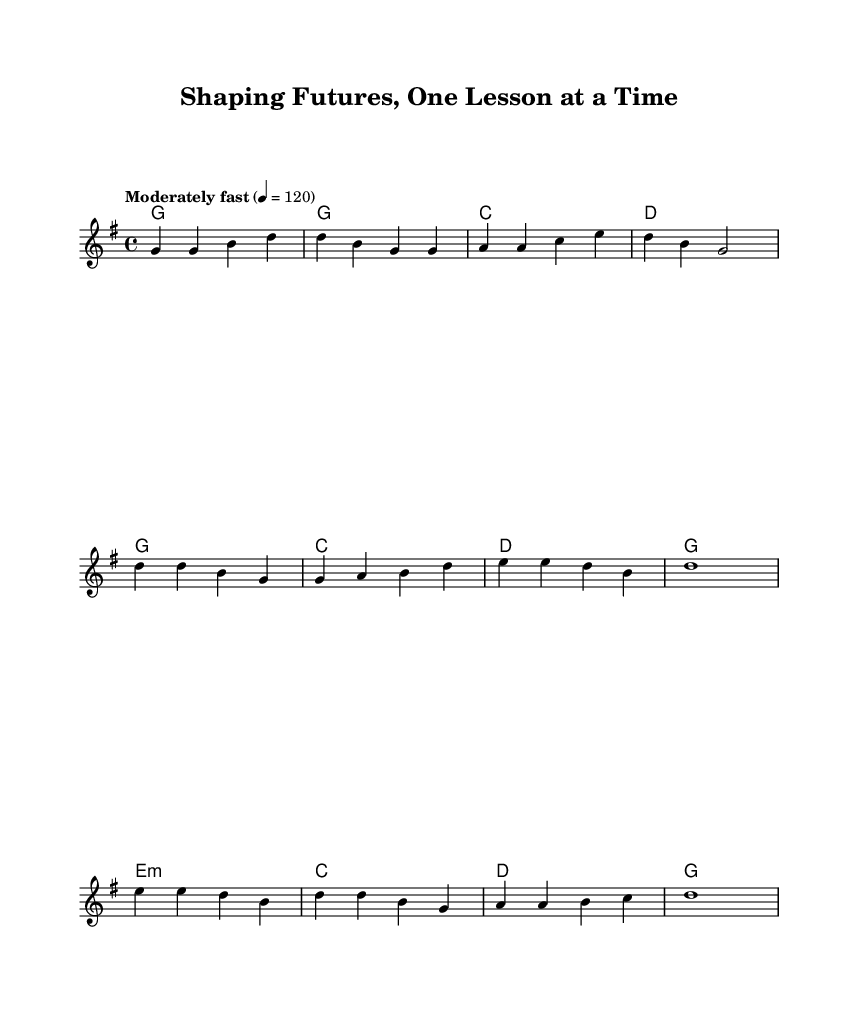What is the key signature of this music? The key signature is G major, which has one sharp (F#). This can be identified by looking at the key signature at the beginning of the staff.
Answer: G major What is the time signature of this music? The time signature is 4/4, which indicates four beats per measure and a quarter note receives one beat. This is indicated near the beginning of the sheet music.
Answer: 4/4 What is the tempo marking for this piece? The tempo marking is "Moderately fast" set at 120 beats per minute, which is marked above the staff. This indicates the speed at which the piece should be played.
Answer: Moderately fast How many bars are in the verse section? The verse section consists of four bars of music, which can be counted in the melodic measures provided. Each line of music typically corresponds to a set number of bars.
Answer: Four What is the overall theme of the lyrics? The overall theme of the lyrics is about shaping futures and inspiring students, as seen in the phrases used throughout the verses and chorus. The emphasis is on guidance and growth.
Answer: Inspiration What type of harmony is used in the bridge section? The harmonies in the bridge section follow a minor chord (e minor) followed by major chords. This variation provides emotional depth to the song during this transition.
Answer: Minor 